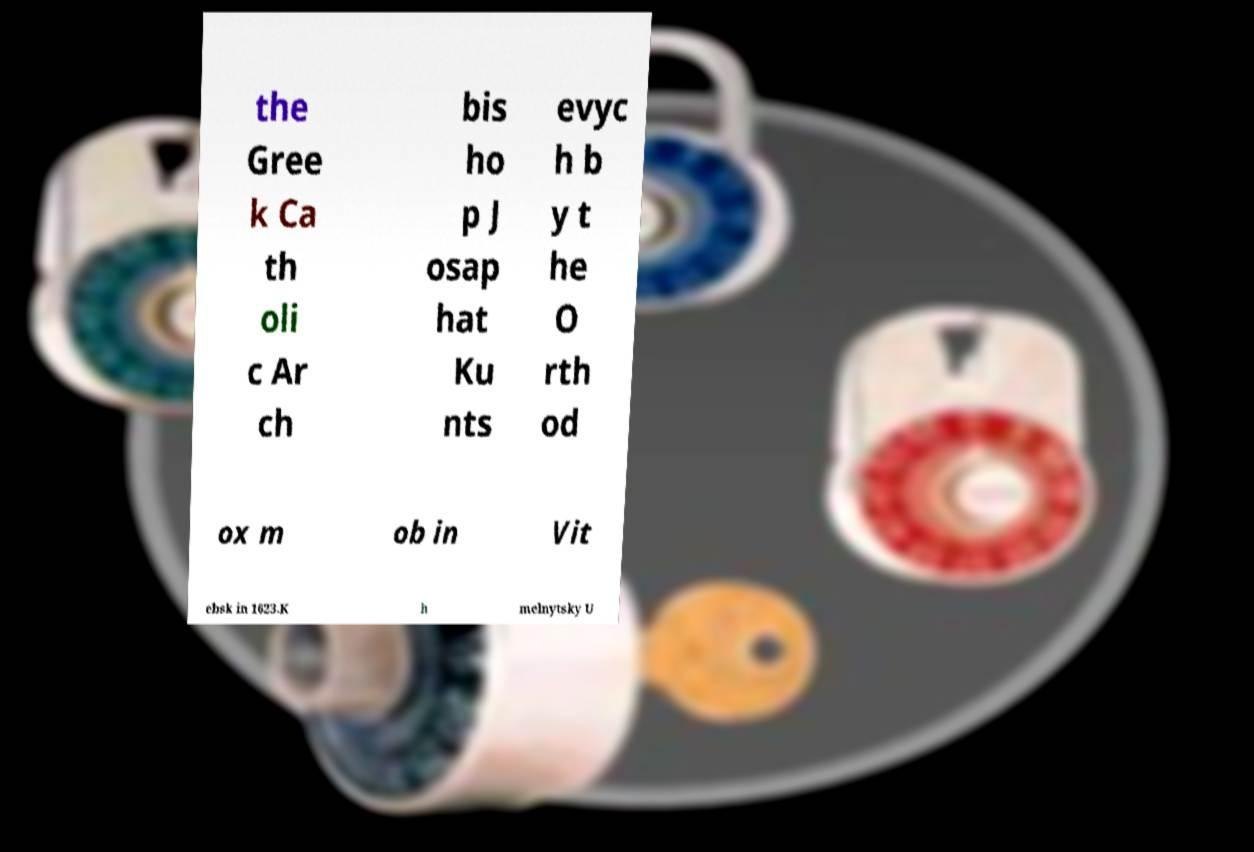There's text embedded in this image that I need extracted. Can you transcribe it verbatim? the Gree k Ca th oli c Ar ch bis ho p J osap hat Ku nts evyc h b y t he O rth od ox m ob in Vit ebsk in 1623.K h melnytsky U 